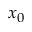Convert formula to latex. <formula><loc_0><loc_0><loc_500><loc_500>x _ { 0 }</formula> 